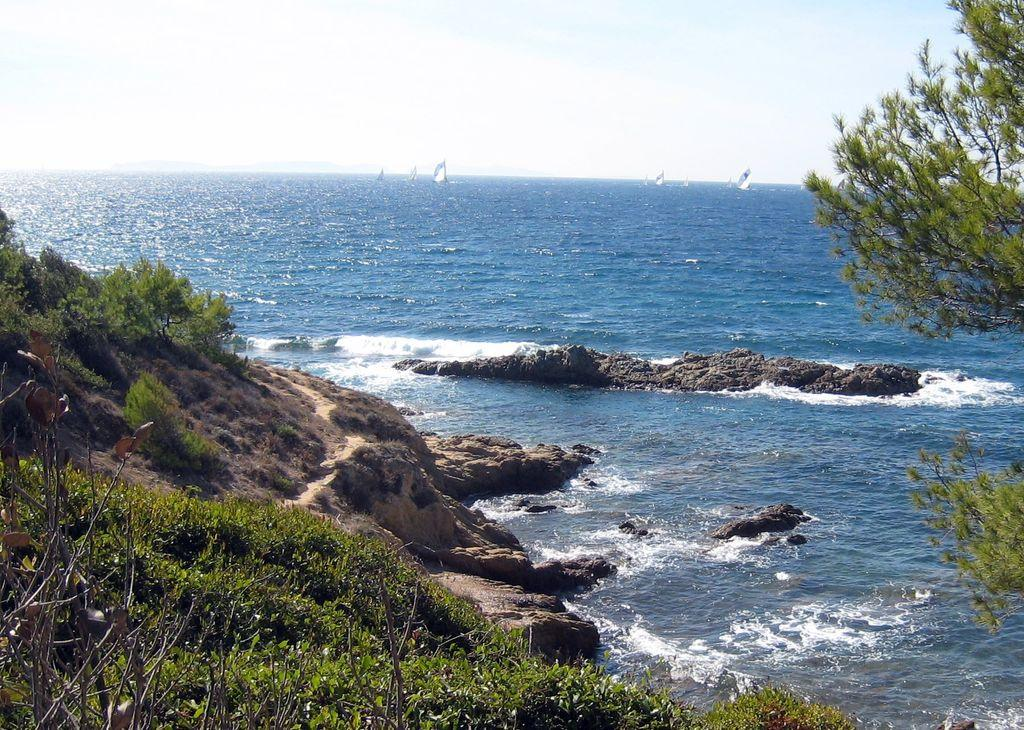What type of vegetation is on the left side of the image? There are plants on the left side of the image. What type of tree is on the right side of the image? There is a tree on the right side of the image. What can be seen in the image besides the plants and tree? There is water visible in the image. What is visible at the top of the image? The sky is visible at the top of the image. What unit of measurement is used to determine the value of the land in the image? There is no reference to land or any measurements in the image, so it is not possible to answer that question. 